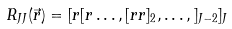<formula> <loc_0><loc_0><loc_500><loc_500>R _ { J J } ( \vec { r } ) = [ r [ r \dots , [ r r ] _ { 2 } , \dots , ] _ { J - 2 } ] _ { J }</formula> 